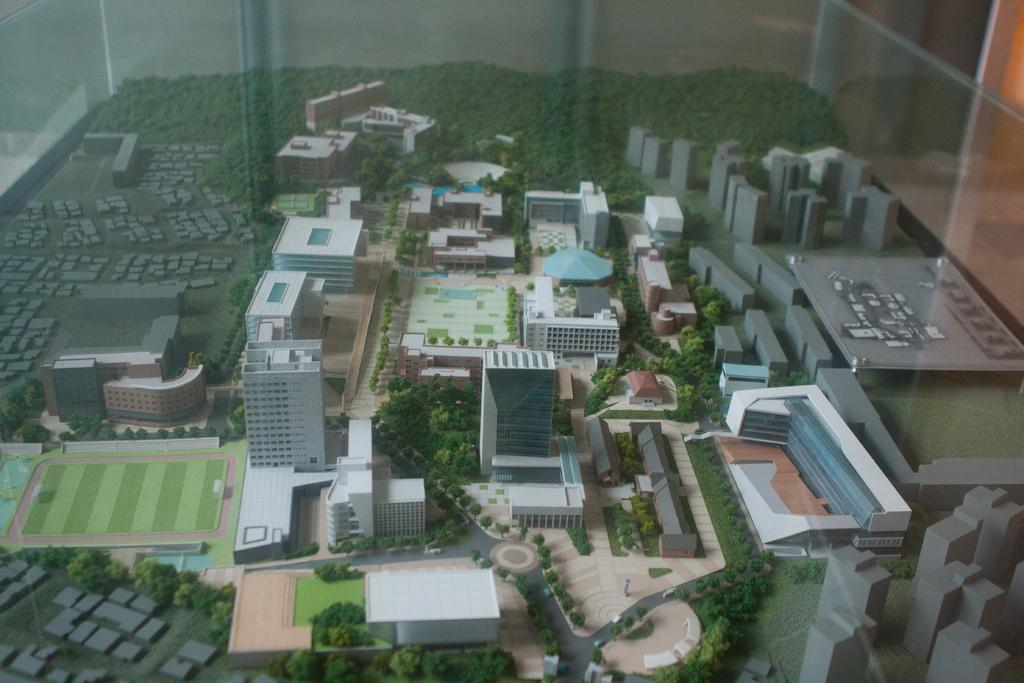What type of structures are present in the image? The image contains miniature buildings. What other elements can be seen in the image besides the buildings? There are plants, trees, and a road in the image. What type of space is visible in the image? There is no space visible in the image; it contains miniature buildings, plants, trees, and a road. Can you see any cobwebs in the image? There are no cobwebs present in the image. 